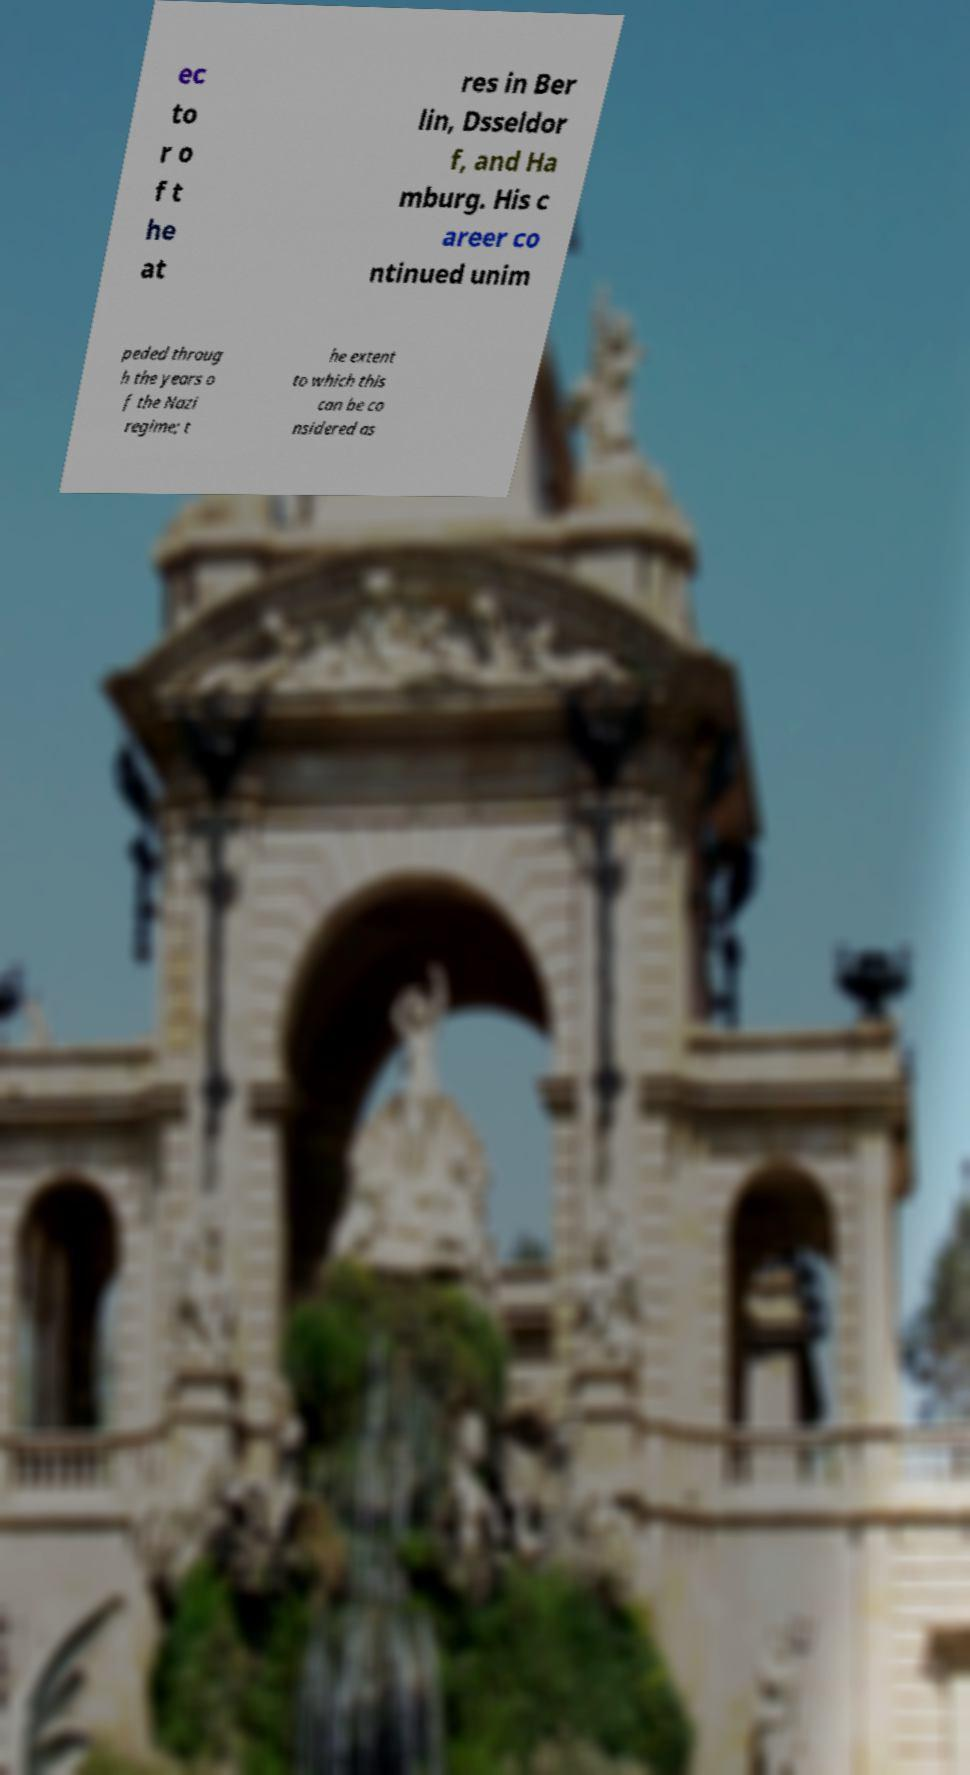Can you read and provide the text displayed in the image?This photo seems to have some interesting text. Can you extract and type it out for me? ec to r o f t he at res in Ber lin, Dsseldor f, and Ha mburg. His c areer co ntinued unim peded throug h the years o f the Nazi regime; t he extent to which this can be co nsidered as 